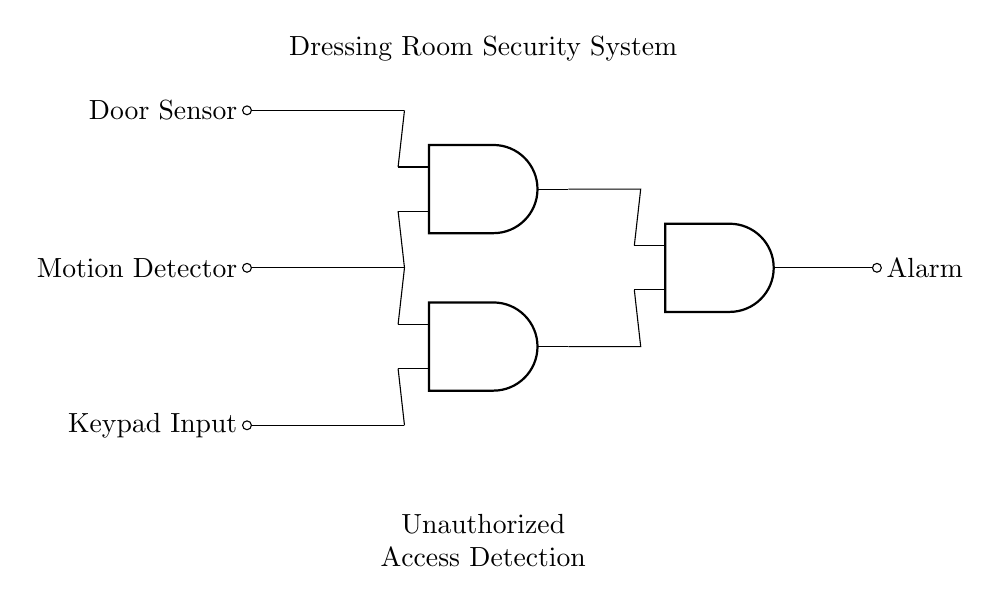What are the input components in this circuit? The circuit's inputs are the Door Sensor, Motion Detector, and Keypad Input. These components are shown at the left side of the diagram and labeled clearly.
Answer: Door Sensor, Motion Detector, Keypad Input How many AND gates are used in the circuit? There are three AND gates present in the circuit, identifiable by the presence of three symbols labeled as AND gates.
Answer: 3 What happens if all inputs are active? If all inputs (Door Sensor, Motion Detector, Keypad Input) are active, the output from the last AND gate, which is connected to the alarm, will trigger, indicating unauthorized access. This follows the AND gate logic where all conditions must be true for the output to be high.
Answer: Alarm triggers What is the output of the circuit? The output of the circuit is the Alarm, which is shown as the output connected to the last AND gate in the structure.
Answer: Alarm Explain how the unauthorized access detection works in this system? The unauthorized access detection works by requiring all three input components (Door Sensor, Motion Detector, and Keypad Input) to be active (true) for the output (Alarm) to be activated. This is a characteristic of AND gates, which only produce a high output when all their inputs are high. The connections from the sensors to the gates show they are wired to create this condition.
Answer: All inputs must be active for the Alarm to trigger What is the primary function of the AND gates in this circuit? The primary function of the AND gates in this circuit is to evaluate the status of the inputs. They will output a high signal only when all the input signals are high, which indicates that the conditions for unauthorized access are met.
Answer: Evaluate input status 